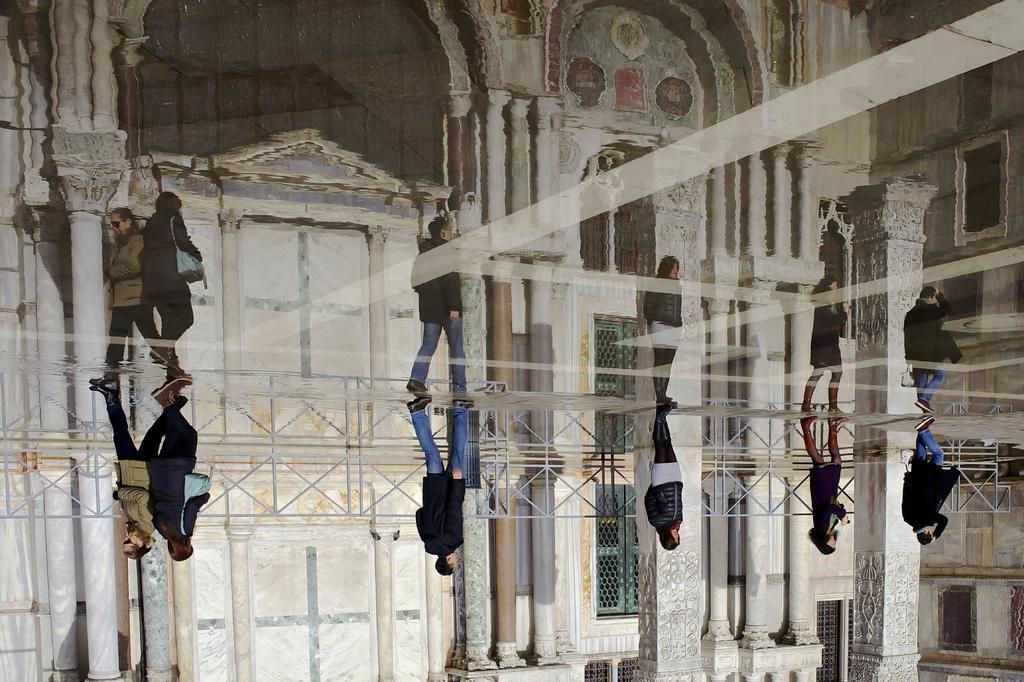Could you give a brief overview of what you see in this image? In this image we can see persons walking on the floor, water and a building in the background. 